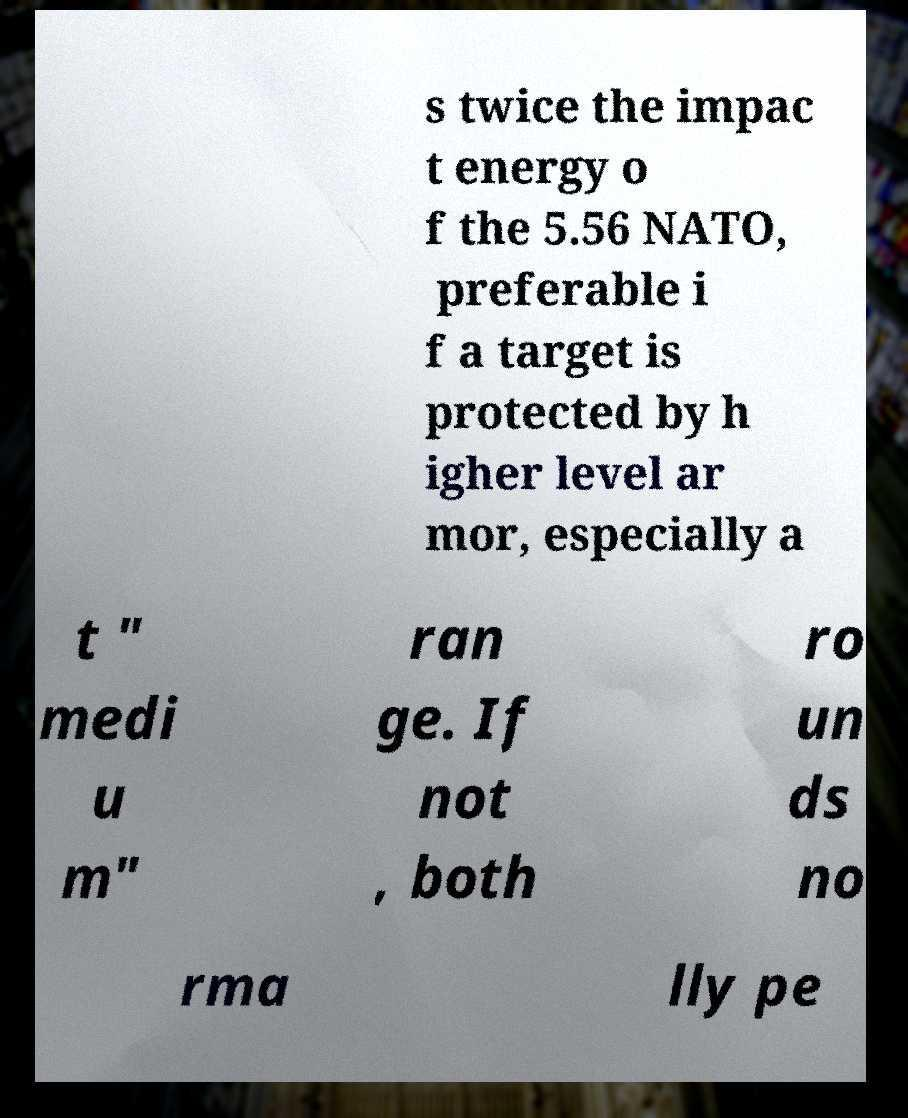Can you read and provide the text displayed in the image?This photo seems to have some interesting text. Can you extract and type it out for me? s twice the impac t energy o f the 5.56 NATO, preferable i f a target is protected by h igher level ar mor, especially a t " medi u m" ran ge. If not , both ro un ds no rma lly pe 